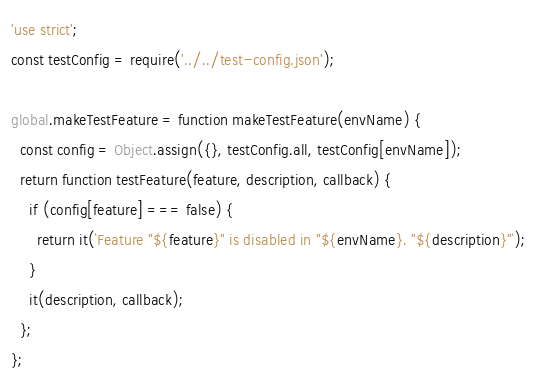Convert code to text. <code><loc_0><loc_0><loc_500><loc_500><_JavaScript_>'use strict';
const testConfig = require('../../test-config.json');

global.makeTestFeature = function makeTestFeature(envName) {
  const config = Object.assign({}, testConfig.all, testConfig[envName]);
  return function testFeature(feature, description, callback) {
    if (config[feature] === false) {
      return it(`Feature "${feature}" is disabled in "${envName}. "${description}"`);
    }
    it(description, callback);
  };
};
</code> 